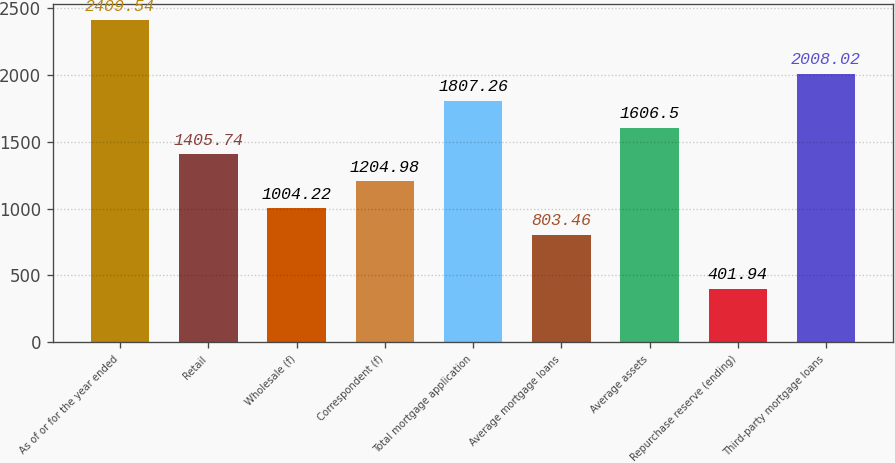Convert chart to OTSL. <chart><loc_0><loc_0><loc_500><loc_500><bar_chart><fcel>As of or for the year ended<fcel>Retail<fcel>Wholesale (f)<fcel>Correspondent (f)<fcel>Total mortgage application<fcel>Average mortgage loans<fcel>Average assets<fcel>Repurchase reserve (ending)<fcel>Third-party mortgage loans<nl><fcel>2409.54<fcel>1405.74<fcel>1004.22<fcel>1204.98<fcel>1807.26<fcel>803.46<fcel>1606.5<fcel>401.94<fcel>2008.02<nl></chart> 